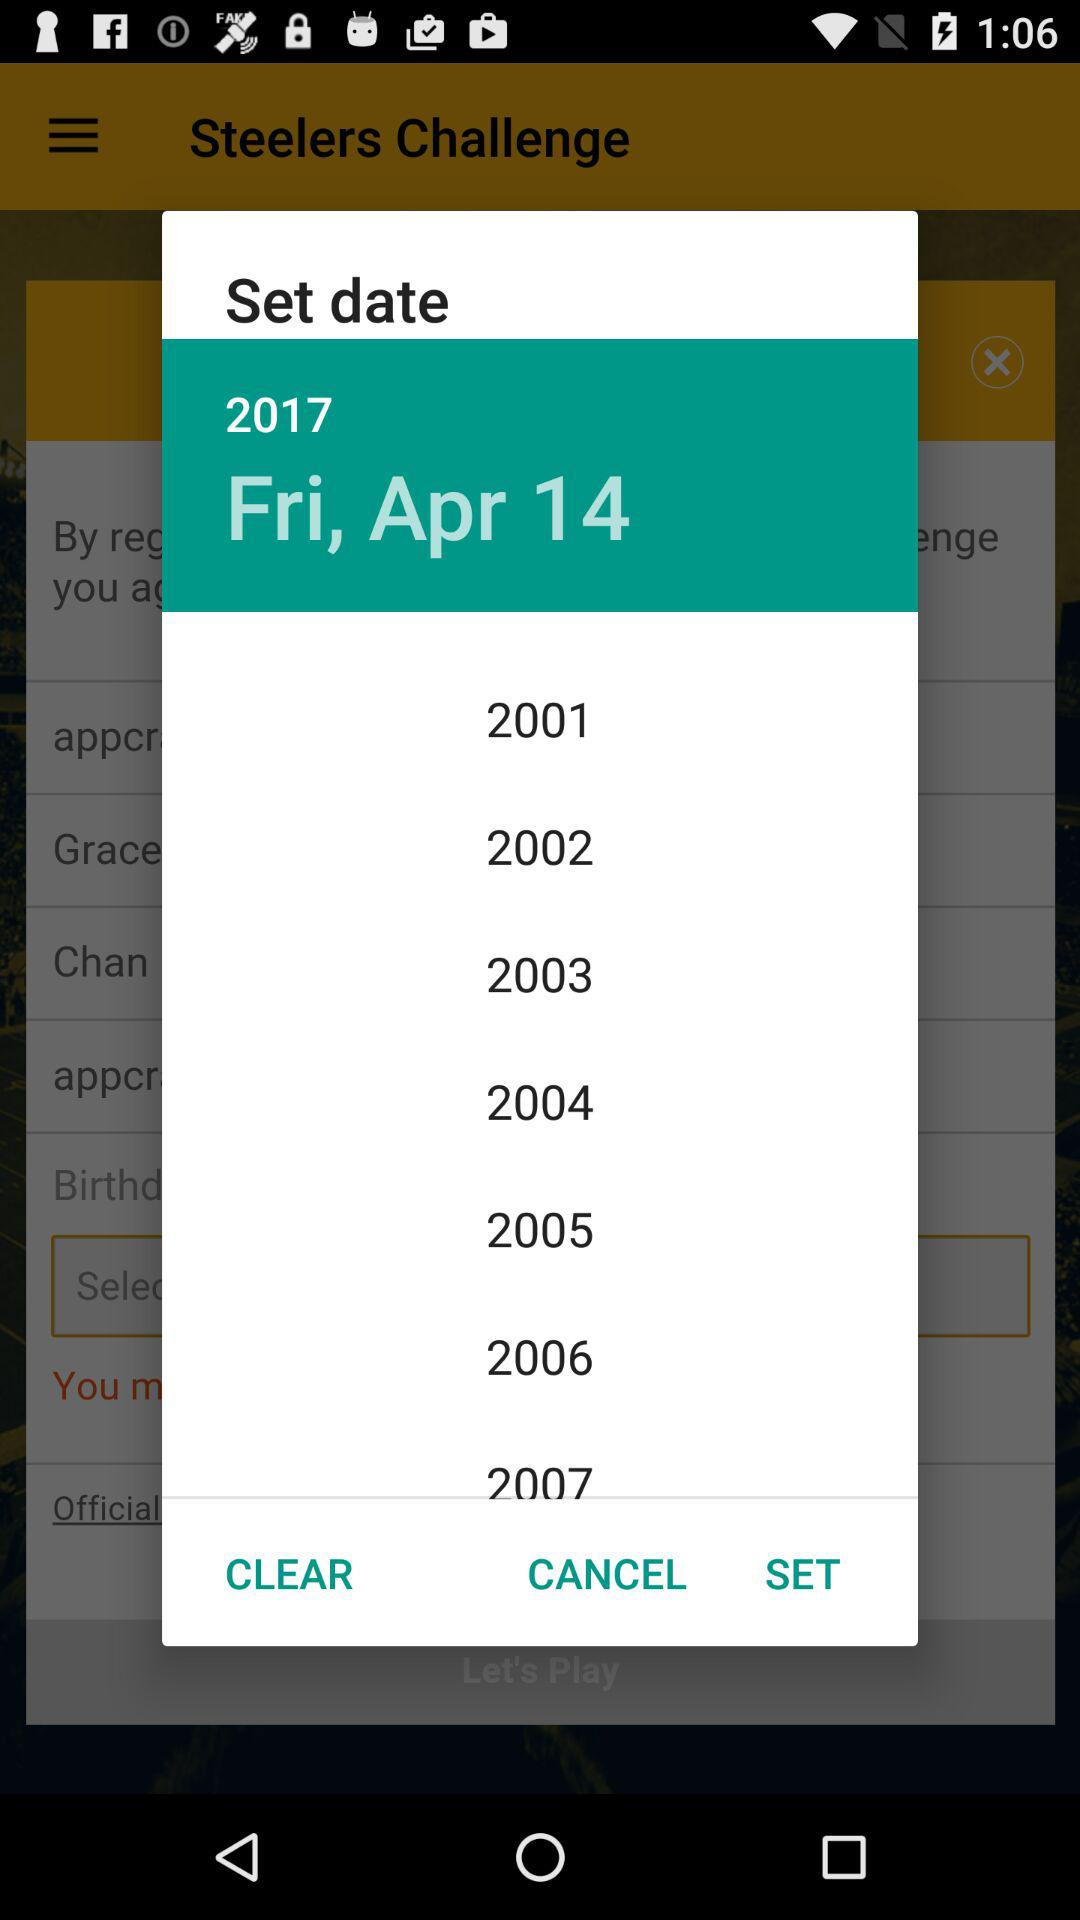What is the difference in years between the first and last year in the date picker?
Answer the question using a single word or phrase. 6 